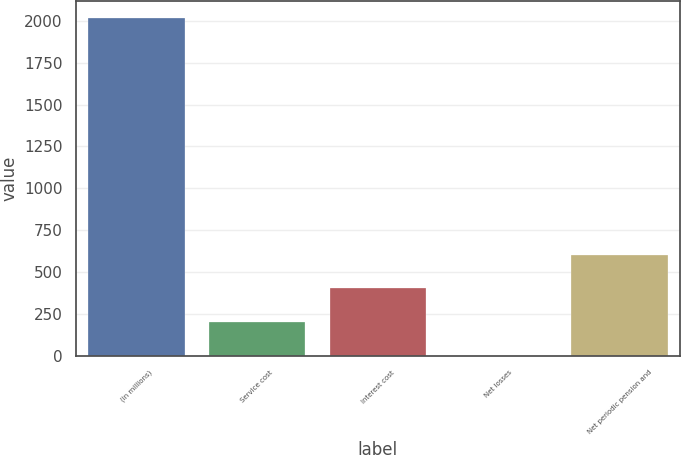<chart> <loc_0><loc_0><loc_500><loc_500><bar_chart><fcel>(in millions)<fcel>Service cost<fcel>Interest cost<fcel>Net losses<fcel>Net periodic pension and<nl><fcel>2014<fcel>203.2<fcel>404.4<fcel>2<fcel>605.6<nl></chart> 